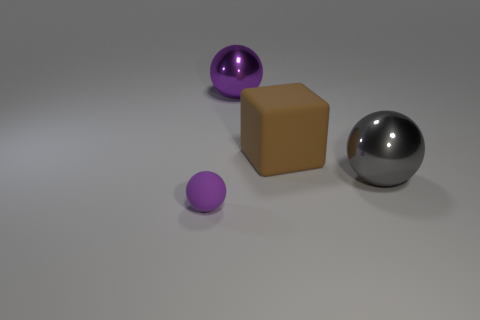Subtract all yellow cubes. How many purple balls are left? 2 Subtract 1 spheres. How many spheres are left? 2 Subtract all gray balls. How many balls are left? 2 Add 2 tiny purple rubber balls. How many objects exist? 6 Subtract all red balls. Subtract all gray cubes. How many balls are left? 3 Subtract all balls. How many objects are left? 1 Add 1 shiny balls. How many shiny balls are left? 3 Add 2 small brown rubber balls. How many small brown rubber balls exist? 2 Subtract 0 green spheres. How many objects are left? 4 Subtract all tiny purple matte things. Subtract all small blocks. How many objects are left? 3 